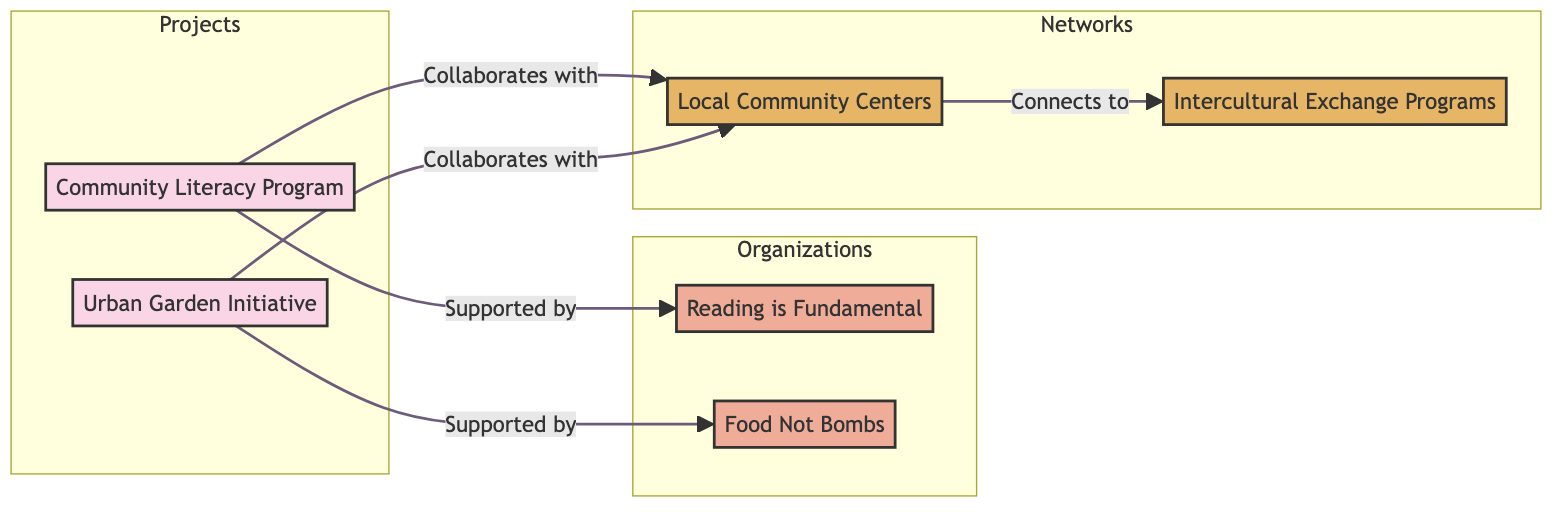What are the total number of nodes in the diagram? The diagram includes six nodes which consist of two projects, two organizations, and two networks. Counting all these nodes together gives a total of 6.
Answer: 6 Which organization supports the Community Literacy Program? The directed edge from the Community Literacy Program to the organization indicates that it is supported by Reading is Fundamental. This relationship is clearly specified in the diagram.
Answer: Reading is Fundamental How many projects collaborate with Local Community Centers? Both projects, the Community Literacy Program and Urban Garden Initiative, show collaboration with Local Community Centers. Therefore, the count of projects collaborating with this network is 2.
Answer: 2 What is the relationship between the Urban Garden Initiative and Food Not Bombs? There is no direct edge indicating a relationship between the Urban Garden Initiative and Food Not Bombs. The Urban Garden Initiative supports Food Not Bombs but there is no collaboration shown, so we can state that they do not have a direct relationship depicted in the diagram.
Answer: None Which two networks are connected in the diagram? According to the diagram, the Local Community Centers connect to the Intercultural Exchange Programs, indicating a network relationship. This connection suggests an interaction between these two networks.
Answer: Local Community Centers and Intercultural Exchange Programs In the context of the diagram, how many organizations are involved in supporting community projects? The diagram shows two organizations, Reading is Fundamental and Food Not Bombs, both of which support the community projects represented. This gives a total of 2 organizations involved in this capacity.
Answer: 2 What is the type of relationship between Local Community Centers and Intercultural Exchange Programs? The connection between Local Community Centers and Intercultural Exchange Programs is established as "Connects to," indicating a linking characteristic of these networks within the project structure.
Answer: Connects to Which project primarily aims at improving literacy? The Community Literacy Program is highlighted in the diagram as the project explicitly dedicated to enhancing literacy among marginalized communities, as described.
Answer: Community Literacy Program 